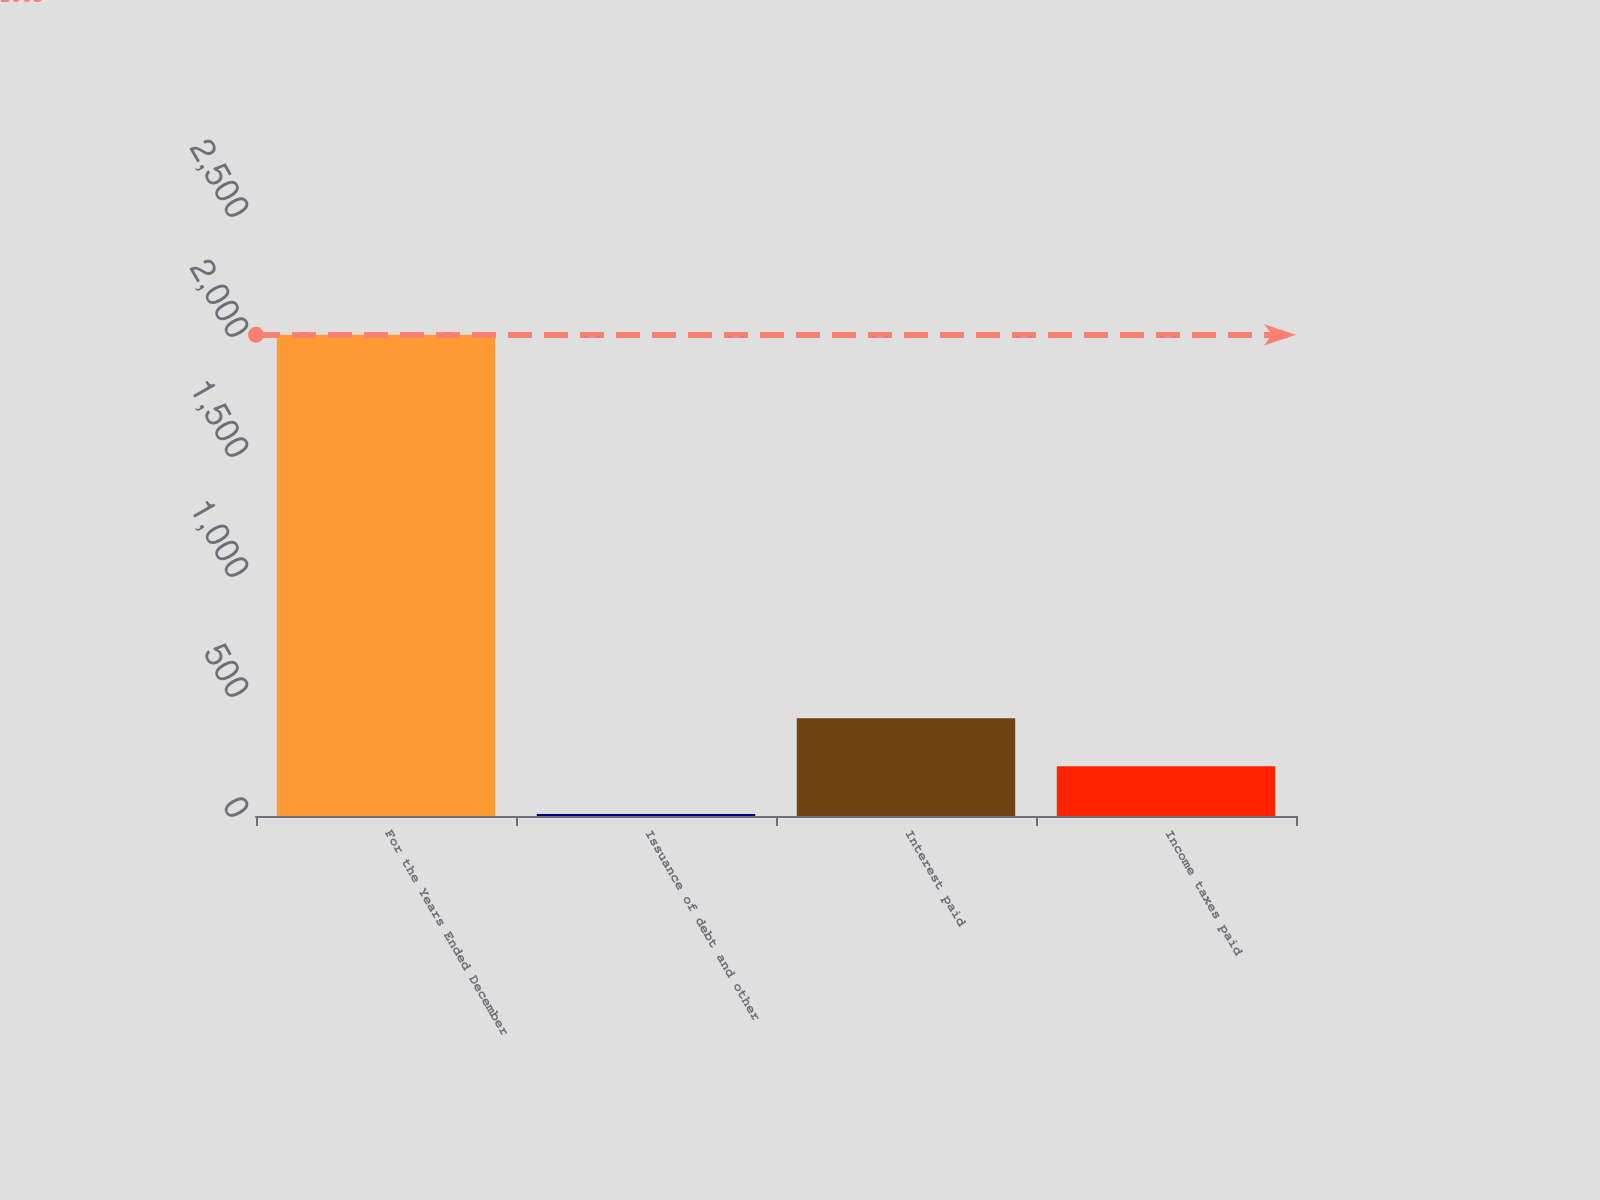<chart> <loc_0><loc_0><loc_500><loc_500><bar_chart><fcel>For the Years Ended December<fcel>Issuance of debt and other<fcel>Interest paid<fcel>Income taxes paid<nl><fcel>2005<fcel>8<fcel>407.4<fcel>207.7<nl></chart> 